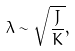Convert formula to latex. <formula><loc_0><loc_0><loc_500><loc_500>\lambda \sim \sqrt { \frac { J } { K } } ,</formula> 